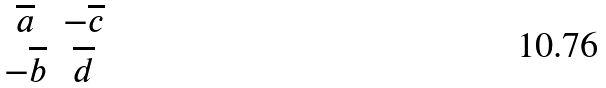<formula> <loc_0><loc_0><loc_500><loc_500>\begin{matrix} \overline { a } & - \overline { c } \\ - \overline { b } & \overline { d } \end{matrix}</formula> 